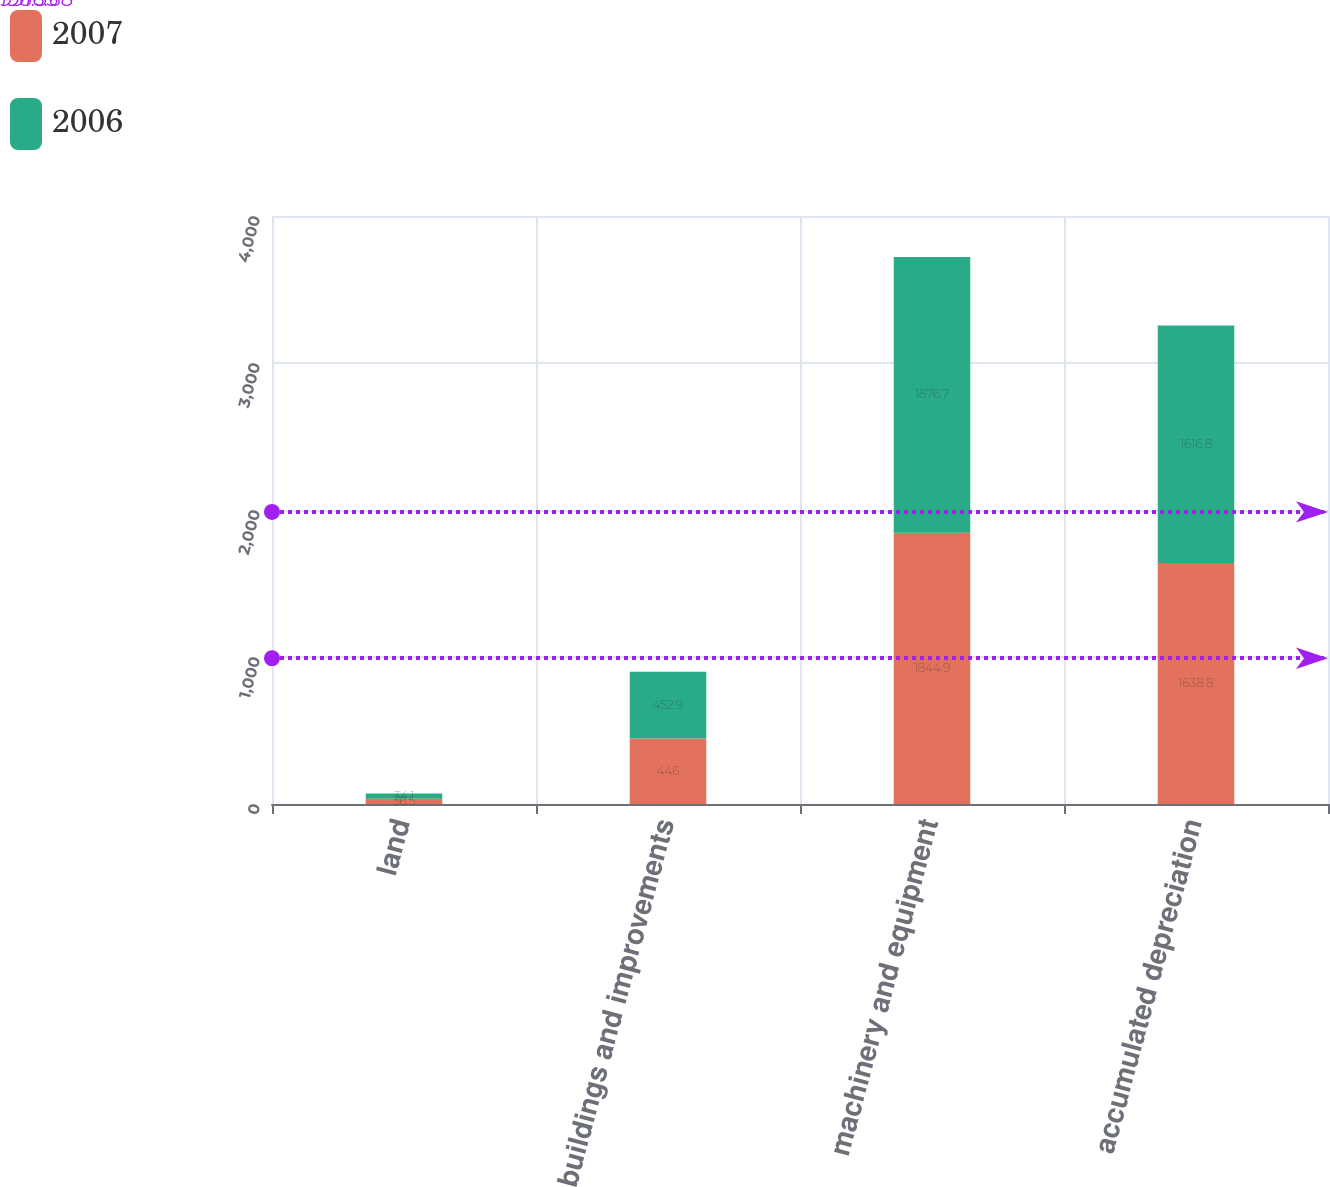Convert chart to OTSL. <chart><loc_0><loc_0><loc_500><loc_500><stacked_bar_chart><ecel><fcel>land<fcel>buildings and improvements<fcel>machinery and equipment<fcel>accumulated depreciation<nl><fcel>2007<fcel>36.5<fcel>446<fcel>1844.9<fcel>1638.8<nl><fcel>2006<fcel>34.1<fcel>452.9<fcel>1876.7<fcel>1616.8<nl></chart> 